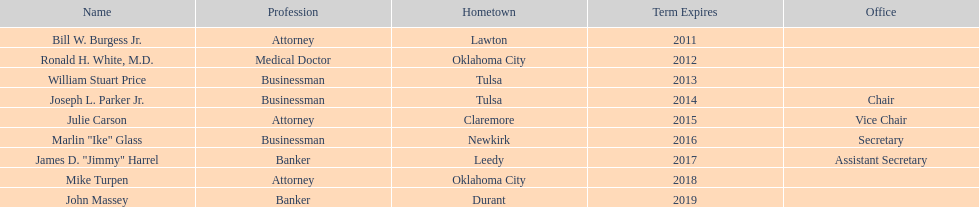Other than william stuart price, which other businessman was born in tulsa? Joseph L. Parker Jr. 